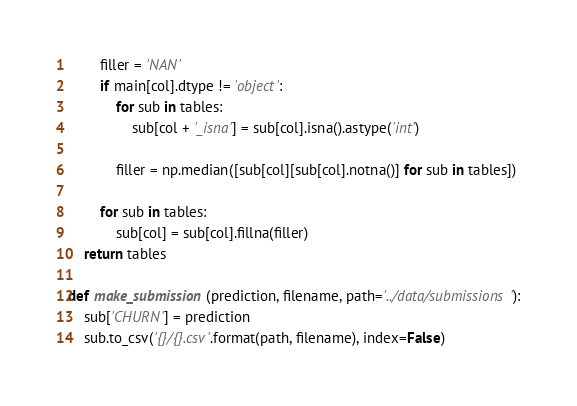Convert code to text. <code><loc_0><loc_0><loc_500><loc_500><_Python_>
        filler = 'NAN'
        if main[col].dtype != 'object':
            for sub in tables:
                sub[col + '_isna'] = sub[col].isna().astype('int')
            
            filler = np.median([sub[col][sub[col].notna()] for sub in tables])

        for sub in tables:
            sub[col] = sub[col].fillna(filler)
    return tables

def make_submission(prediction, filename, path='../data/submissions'):
    sub['CHURN'] = prediction
    sub.to_csv('{}/{}.csv'.format(path, filename), index=False)</code> 